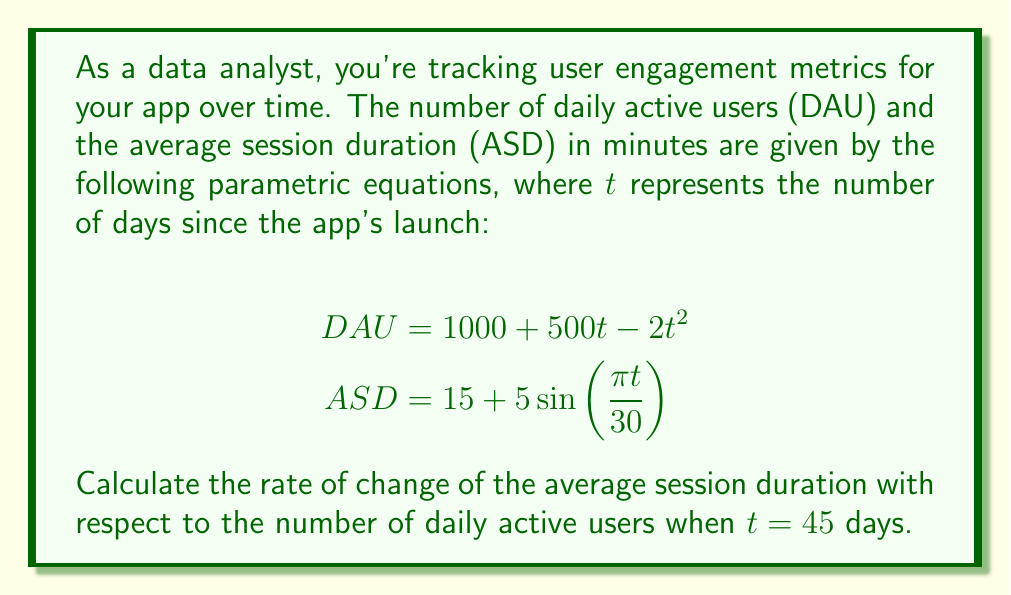Show me your answer to this math problem. To solve this problem, we need to find $\frac{dASD}{dDAU}$ at $t = 45$. We can use the chain rule to express this as:

$$\frac{dASD}{dDAU} = \frac{dASD/dt}{dDAU/dt}$$

Let's break this down step-by-step:

1) First, we need to find $\frac{dASD}{dt}$ and $\frac{dDAU}{dt}$:

   $$\frac{dASD}{dt} = 5 \cdot \frac{\pi}{30} \cos(\frac{\pi t}{30}) = \frac{\pi}{6} \cos(\frac{\pi t}{30})$$
   
   $$\frac{dDAU}{dt} = 500 - 4t$$

2) Now, we need to evaluate these at $t = 45$:

   $$\frac{dASD}{dt}\big|_{t=45} = \frac{\pi}{6} \cos(\frac{\pi \cdot 45}{30}) = \frac{\pi}{6} \cos(\frac{3\pi}{2}) = 0$$
   
   $$\frac{dDAU}{dt}\big|_{t=45} = 500 - 4(45) = 320$$

3) Finally, we can calculate $\frac{dASD}{dDAU}$ at $t = 45$:

   $$\frac{dASD}{dDAU}\big|_{t=45} = \frac{0}{320} = 0$$

This means that at 45 days after the app's launch, the average session duration is not changing with respect to the number of daily active users.
Answer: $\frac{dASD}{dDAU}\big|_{t=45} = 0$ 